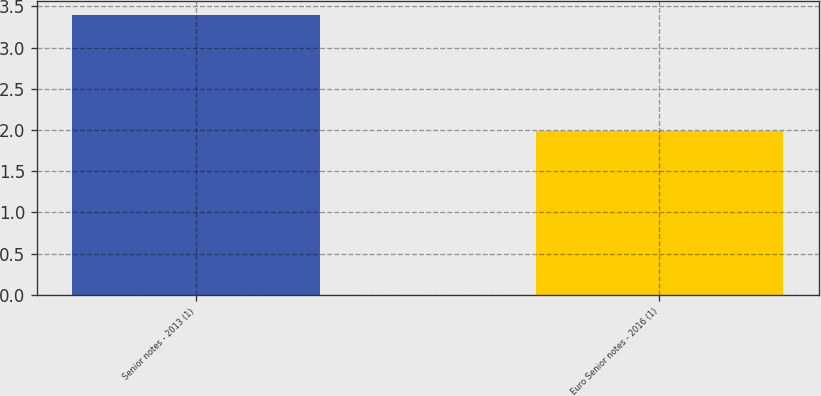<chart> <loc_0><loc_0><loc_500><loc_500><bar_chart><fcel>Senior notes - 2013 (1)<fcel>Euro Senior notes - 2016 (1)<nl><fcel>3.39<fcel>1.99<nl></chart> 